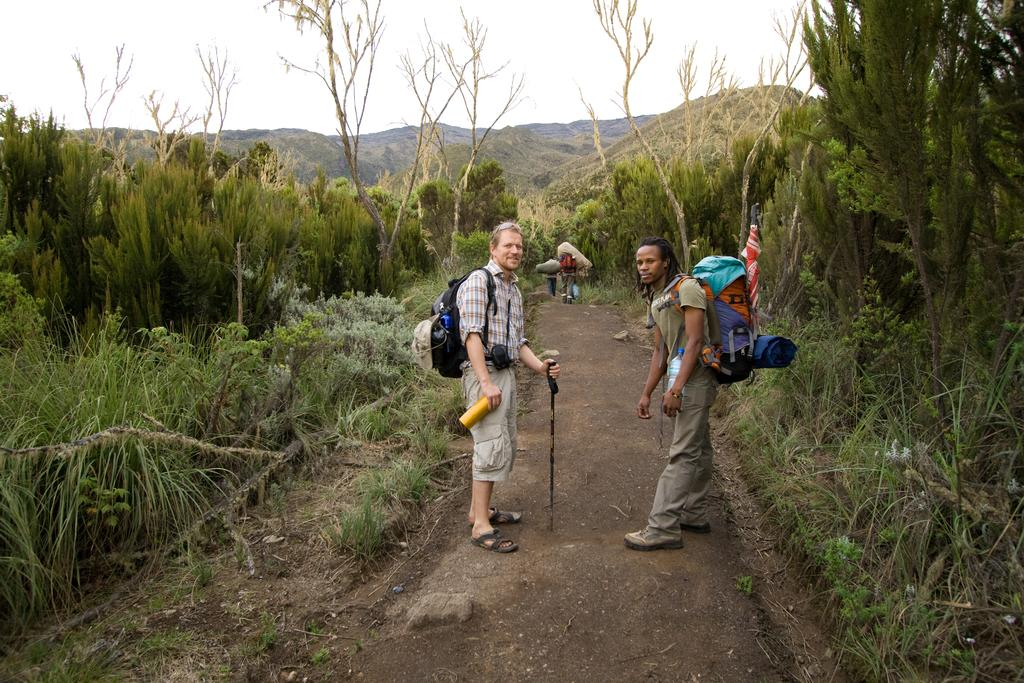How many people are in the image? There are people in the image, but the exact number is not specified. What is visible beneath the people's feet in the image? The ground is visible in the image. What type of vegetation can be seen in the image? There are trees, plants, and grass in the image. What type of landscape feature is present in the image? There are hills in the image. What is visible above the people's heads in the image? The sky is visible in the image. What type of war is being depicted in the image? There is no war depicted in the image; it features people, trees, plants, grass, hills, and the sky. What type of volleyball court can be seen in the image? There is no volleyball court present in the image. 